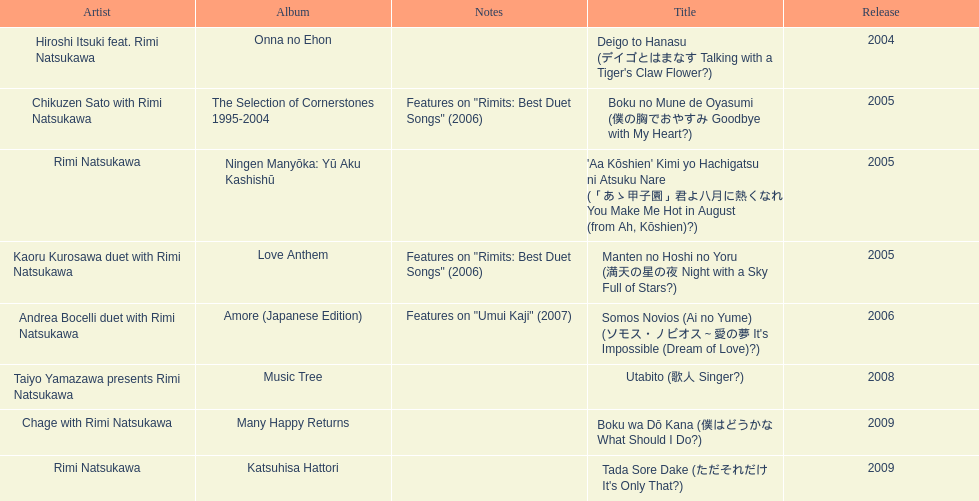What has been the last song this artist has made an other appearance on? Tada Sore Dake. 